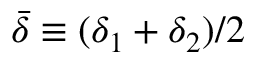<formula> <loc_0><loc_0><loc_500><loc_500>\bar { \delta } \equiv ( \delta _ { 1 } + \delta _ { 2 } ) / 2</formula> 